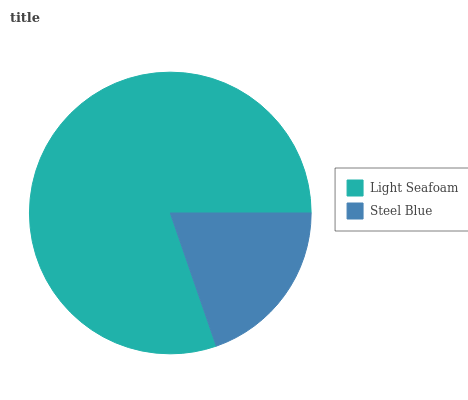Is Steel Blue the minimum?
Answer yes or no. Yes. Is Light Seafoam the maximum?
Answer yes or no. Yes. Is Steel Blue the maximum?
Answer yes or no. No. Is Light Seafoam greater than Steel Blue?
Answer yes or no. Yes. Is Steel Blue less than Light Seafoam?
Answer yes or no. Yes. Is Steel Blue greater than Light Seafoam?
Answer yes or no. No. Is Light Seafoam less than Steel Blue?
Answer yes or no. No. Is Light Seafoam the high median?
Answer yes or no. Yes. Is Steel Blue the low median?
Answer yes or no. Yes. Is Steel Blue the high median?
Answer yes or no. No. Is Light Seafoam the low median?
Answer yes or no. No. 